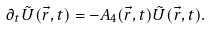<formula> <loc_0><loc_0><loc_500><loc_500>\partial _ { t } \tilde { U } ( \vec { r } , t ) = - A _ { 4 } ( \vec { r } , t ) \tilde { U } ( \vec { r } , t ) .</formula> 